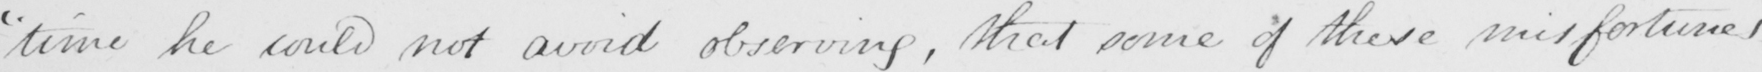Can you tell me what this handwritten text says? " time he could not avoid observing , that some of these misfortunes 